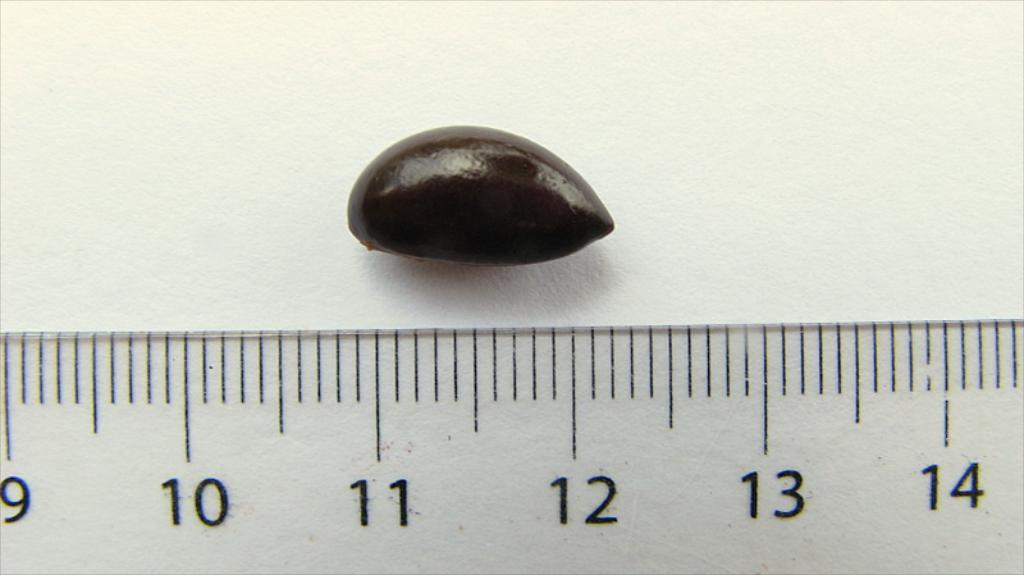<image>
Describe the image concisely. A bean positioned over the 11 to 12 inch mark on a ruler. 